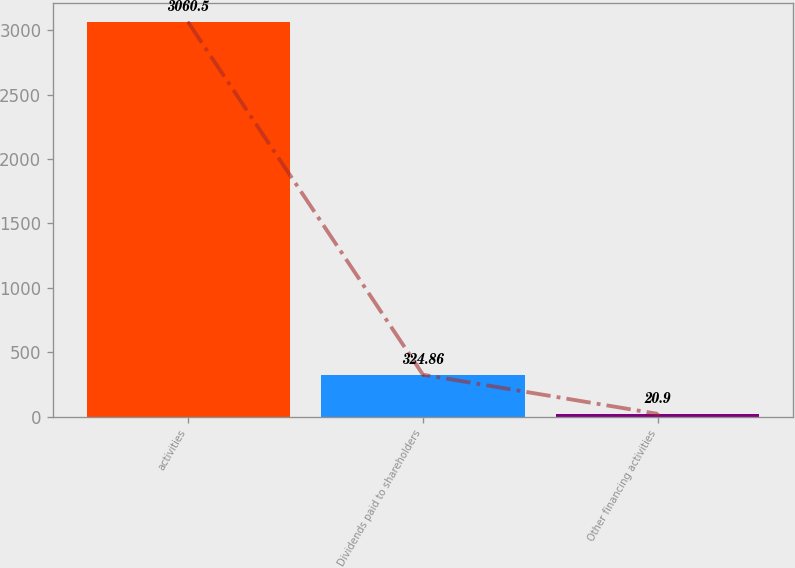Convert chart to OTSL. <chart><loc_0><loc_0><loc_500><loc_500><bar_chart><fcel>activities<fcel>Dividends paid to shareholders<fcel>Other financing activities<nl><fcel>3060.5<fcel>324.86<fcel>20.9<nl></chart> 